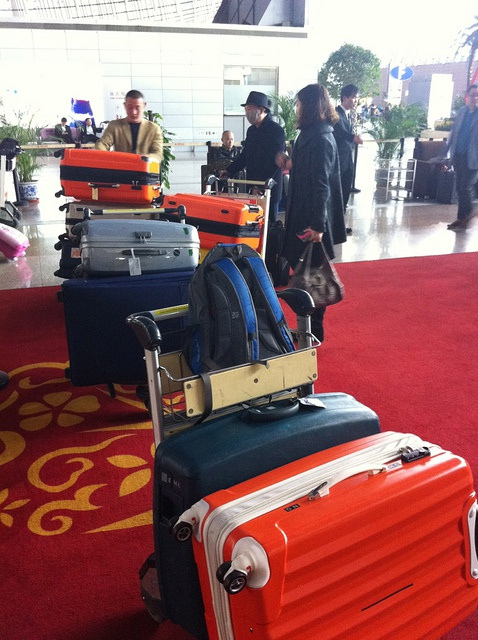Describe the objects in this image and their specific colors. I can see suitcase in ivory, red, brown, and lightgray tones, suitcase in ivory, black, darkblue, blue, and white tones, people in ivory, black, gray, and darkblue tones, backpack in ivory, black, navy, blue, and gray tones, and suitcase in ivory, black, navy, gray, and maroon tones in this image. 